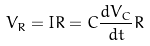Convert formula to latex. <formula><loc_0><loc_0><loc_500><loc_500>V _ { R } = I R = C \frac { d V _ { C } } { d t } R</formula> 